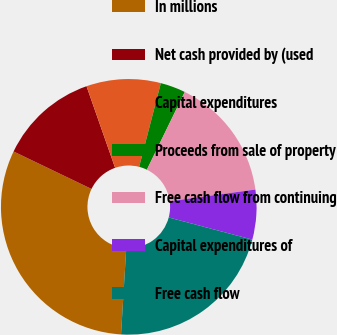<chart> <loc_0><loc_0><loc_500><loc_500><pie_chart><fcel>In millions<fcel>Net cash provided by (used<fcel>Capital expenditures<fcel>Proceeds from sale of property<fcel>Free cash flow from continuing<fcel>Capital expenditures of<fcel>Free cash flow<nl><fcel>31.17%<fcel>12.51%<fcel>9.4%<fcel>3.18%<fcel>15.62%<fcel>6.29%<fcel>21.84%<nl></chart> 